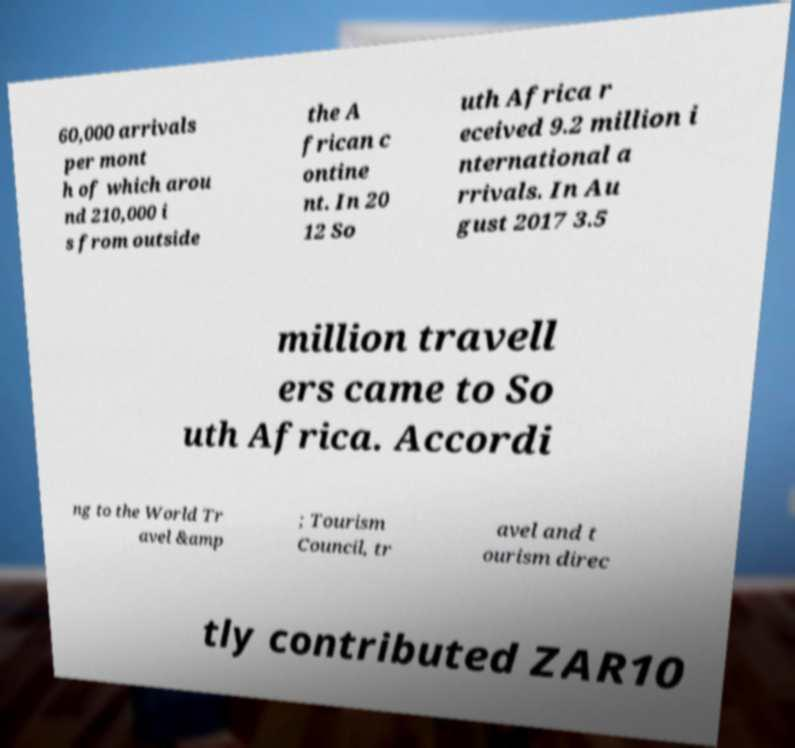Could you extract and type out the text from this image? 60,000 arrivals per mont h of which arou nd 210,000 i s from outside the A frican c ontine nt. In 20 12 So uth Africa r eceived 9.2 million i nternational a rrivals. In Au gust 2017 3.5 million travell ers came to So uth Africa. Accordi ng to the World Tr avel &amp ; Tourism Council, tr avel and t ourism direc tly contributed ZAR10 